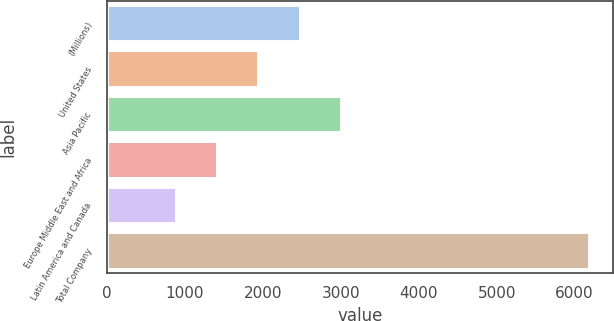<chart> <loc_0><loc_0><loc_500><loc_500><bar_chart><fcel>(Millions)<fcel>United States<fcel>Asia Pacific<fcel>Europe Middle East and Africa<fcel>Latin America and Canada<fcel>Total Company<nl><fcel>2473.6<fcel>1944.4<fcel>3002.8<fcel>1415.2<fcel>886<fcel>6178<nl></chart> 